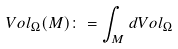<formula> <loc_0><loc_0><loc_500><loc_500>V o l _ { \Omega } ( M ) \colon = \int _ { M } d V o l _ { \Omega }</formula> 